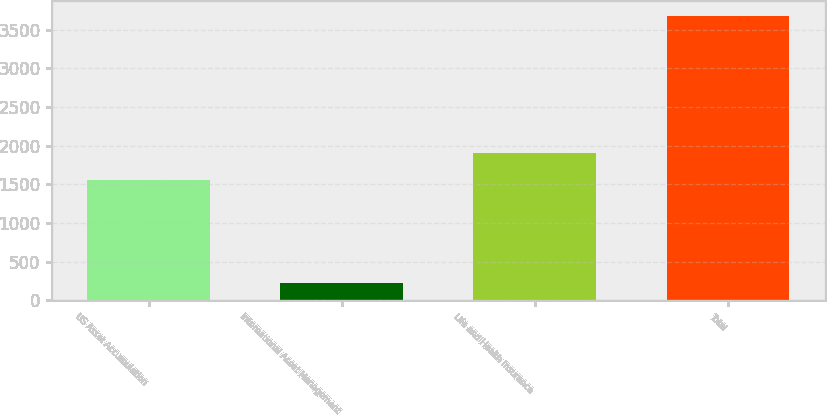Convert chart to OTSL. <chart><loc_0><loc_0><loc_500><loc_500><bar_chart><fcel>US Asset Accumulation<fcel>International Asset Management<fcel>Life and Health Insurance<fcel>Total<nl><fcel>1552.2<fcel>226.5<fcel>1902.7<fcel>3681.4<nl></chart> 